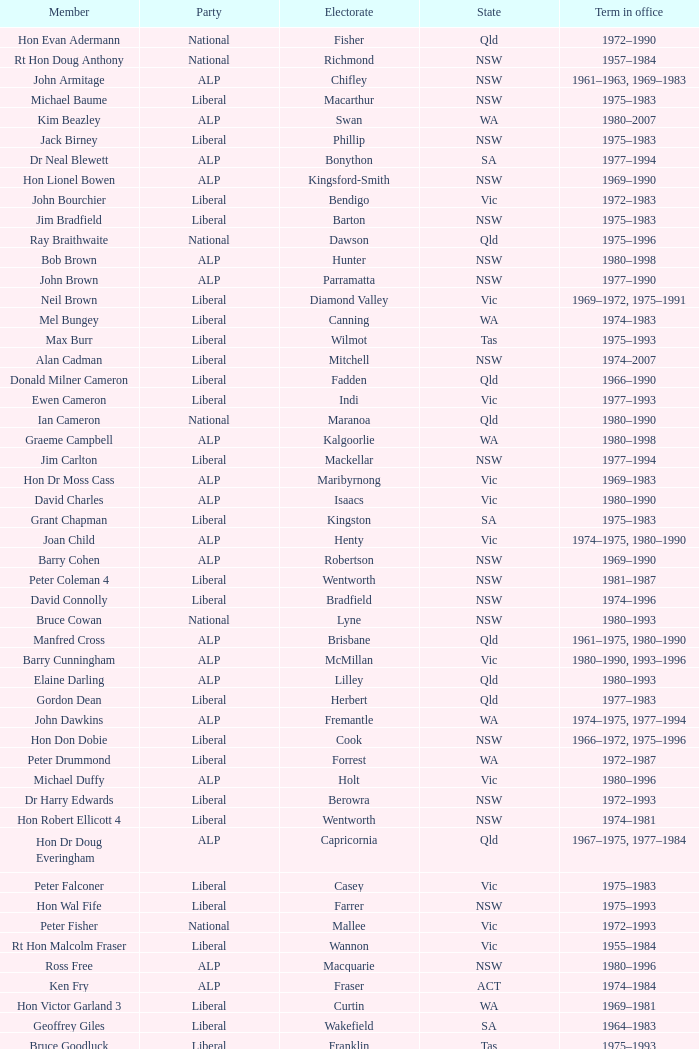When was hon les johnson's tenure in office? 1955–1966, 1969–1984. 